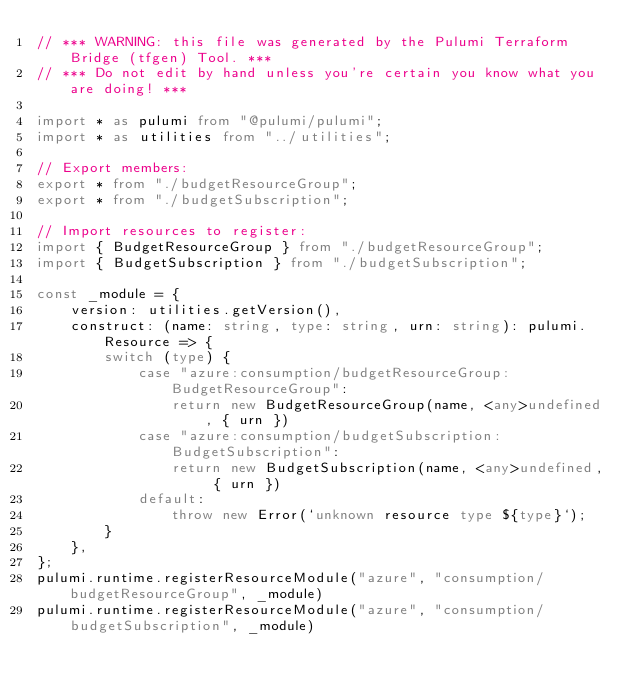<code> <loc_0><loc_0><loc_500><loc_500><_TypeScript_>// *** WARNING: this file was generated by the Pulumi Terraform Bridge (tfgen) Tool. ***
// *** Do not edit by hand unless you're certain you know what you are doing! ***

import * as pulumi from "@pulumi/pulumi";
import * as utilities from "../utilities";

// Export members:
export * from "./budgetResourceGroup";
export * from "./budgetSubscription";

// Import resources to register:
import { BudgetResourceGroup } from "./budgetResourceGroup";
import { BudgetSubscription } from "./budgetSubscription";

const _module = {
    version: utilities.getVersion(),
    construct: (name: string, type: string, urn: string): pulumi.Resource => {
        switch (type) {
            case "azure:consumption/budgetResourceGroup:BudgetResourceGroup":
                return new BudgetResourceGroup(name, <any>undefined, { urn })
            case "azure:consumption/budgetSubscription:BudgetSubscription":
                return new BudgetSubscription(name, <any>undefined, { urn })
            default:
                throw new Error(`unknown resource type ${type}`);
        }
    },
};
pulumi.runtime.registerResourceModule("azure", "consumption/budgetResourceGroup", _module)
pulumi.runtime.registerResourceModule("azure", "consumption/budgetSubscription", _module)
</code> 